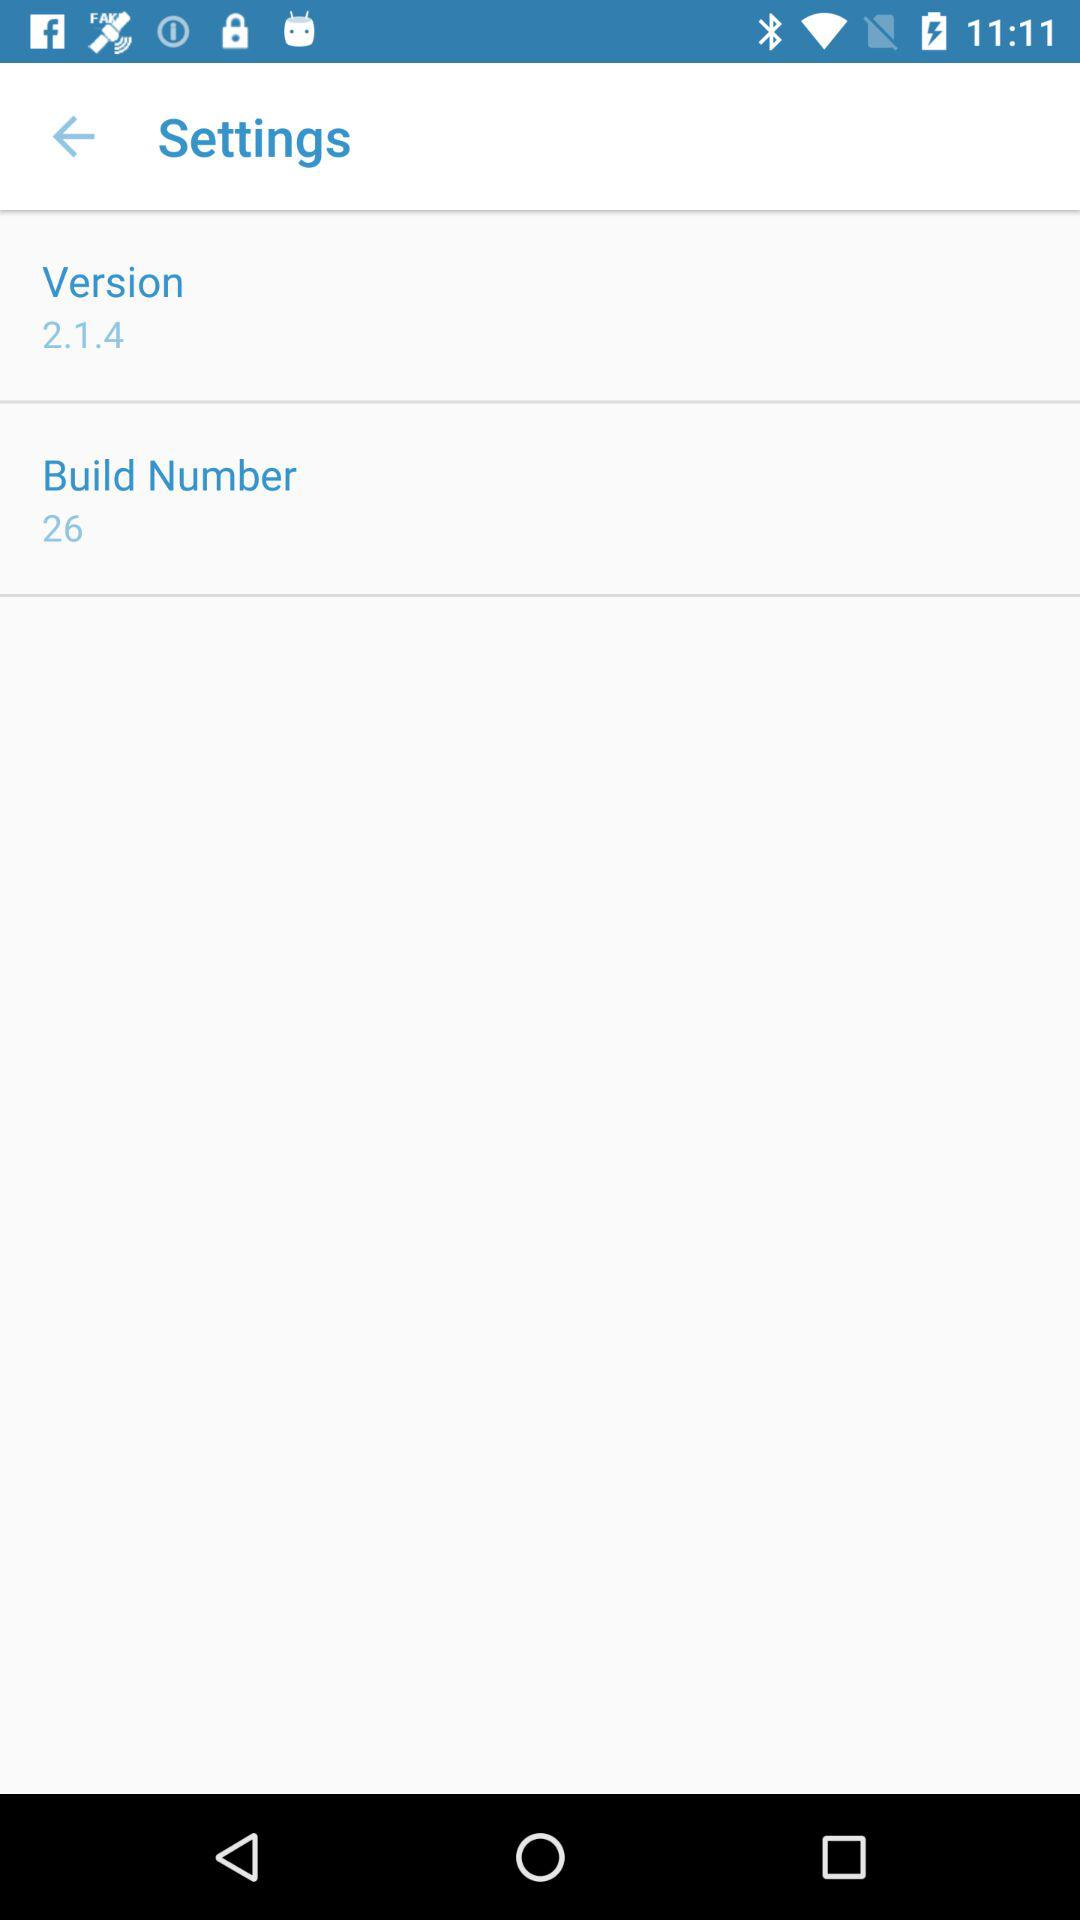What is the build number? The build number is 26. 